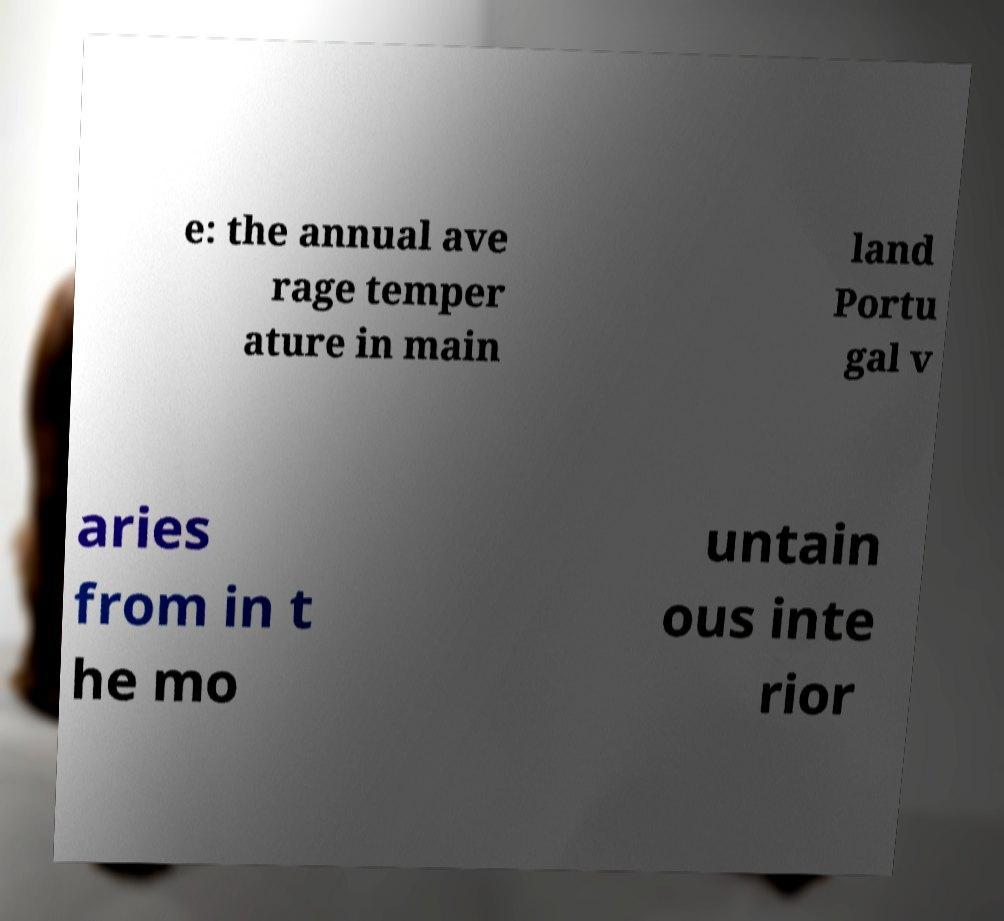Could you assist in decoding the text presented in this image and type it out clearly? e: the annual ave rage temper ature in main land Portu gal v aries from in t he mo untain ous inte rior 